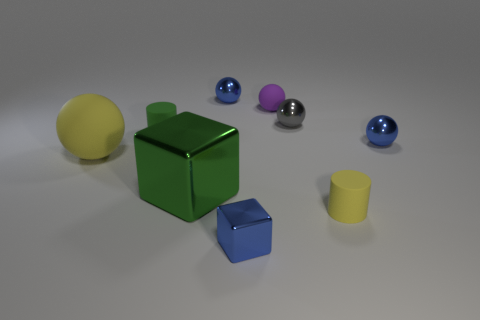Subtract all small blue metal spheres. How many spheres are left? 3 Subtract all gray spheres. How many spheres are left? 4 Subtract all yellow balls. Subtract all purple cubes. How many balls are left? 4 Subtract all cylinders. How many objects are left? 7 Subtract 1 green cubes. How many objects are left? 8 Subtract all large metal balls. Subtract all green cubes. How many objects are left? 8 Add 5 purple things. How many purple things are left? 6 Add 2 tiny brown matte spheres. How many tiny brown matte spheres exist? 2 